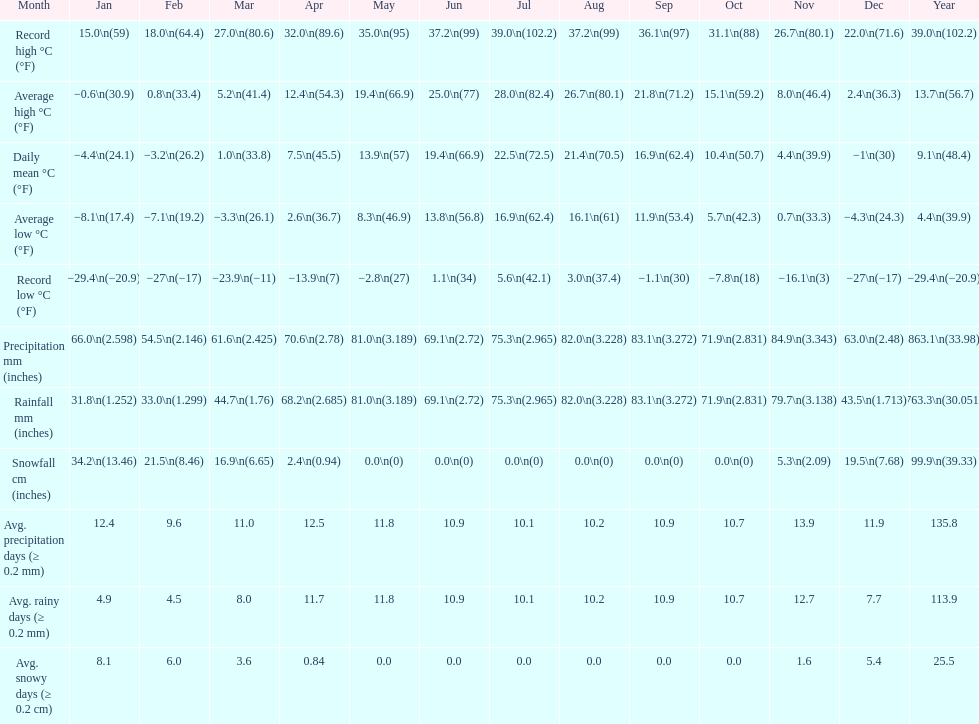0 degrees? 11. 